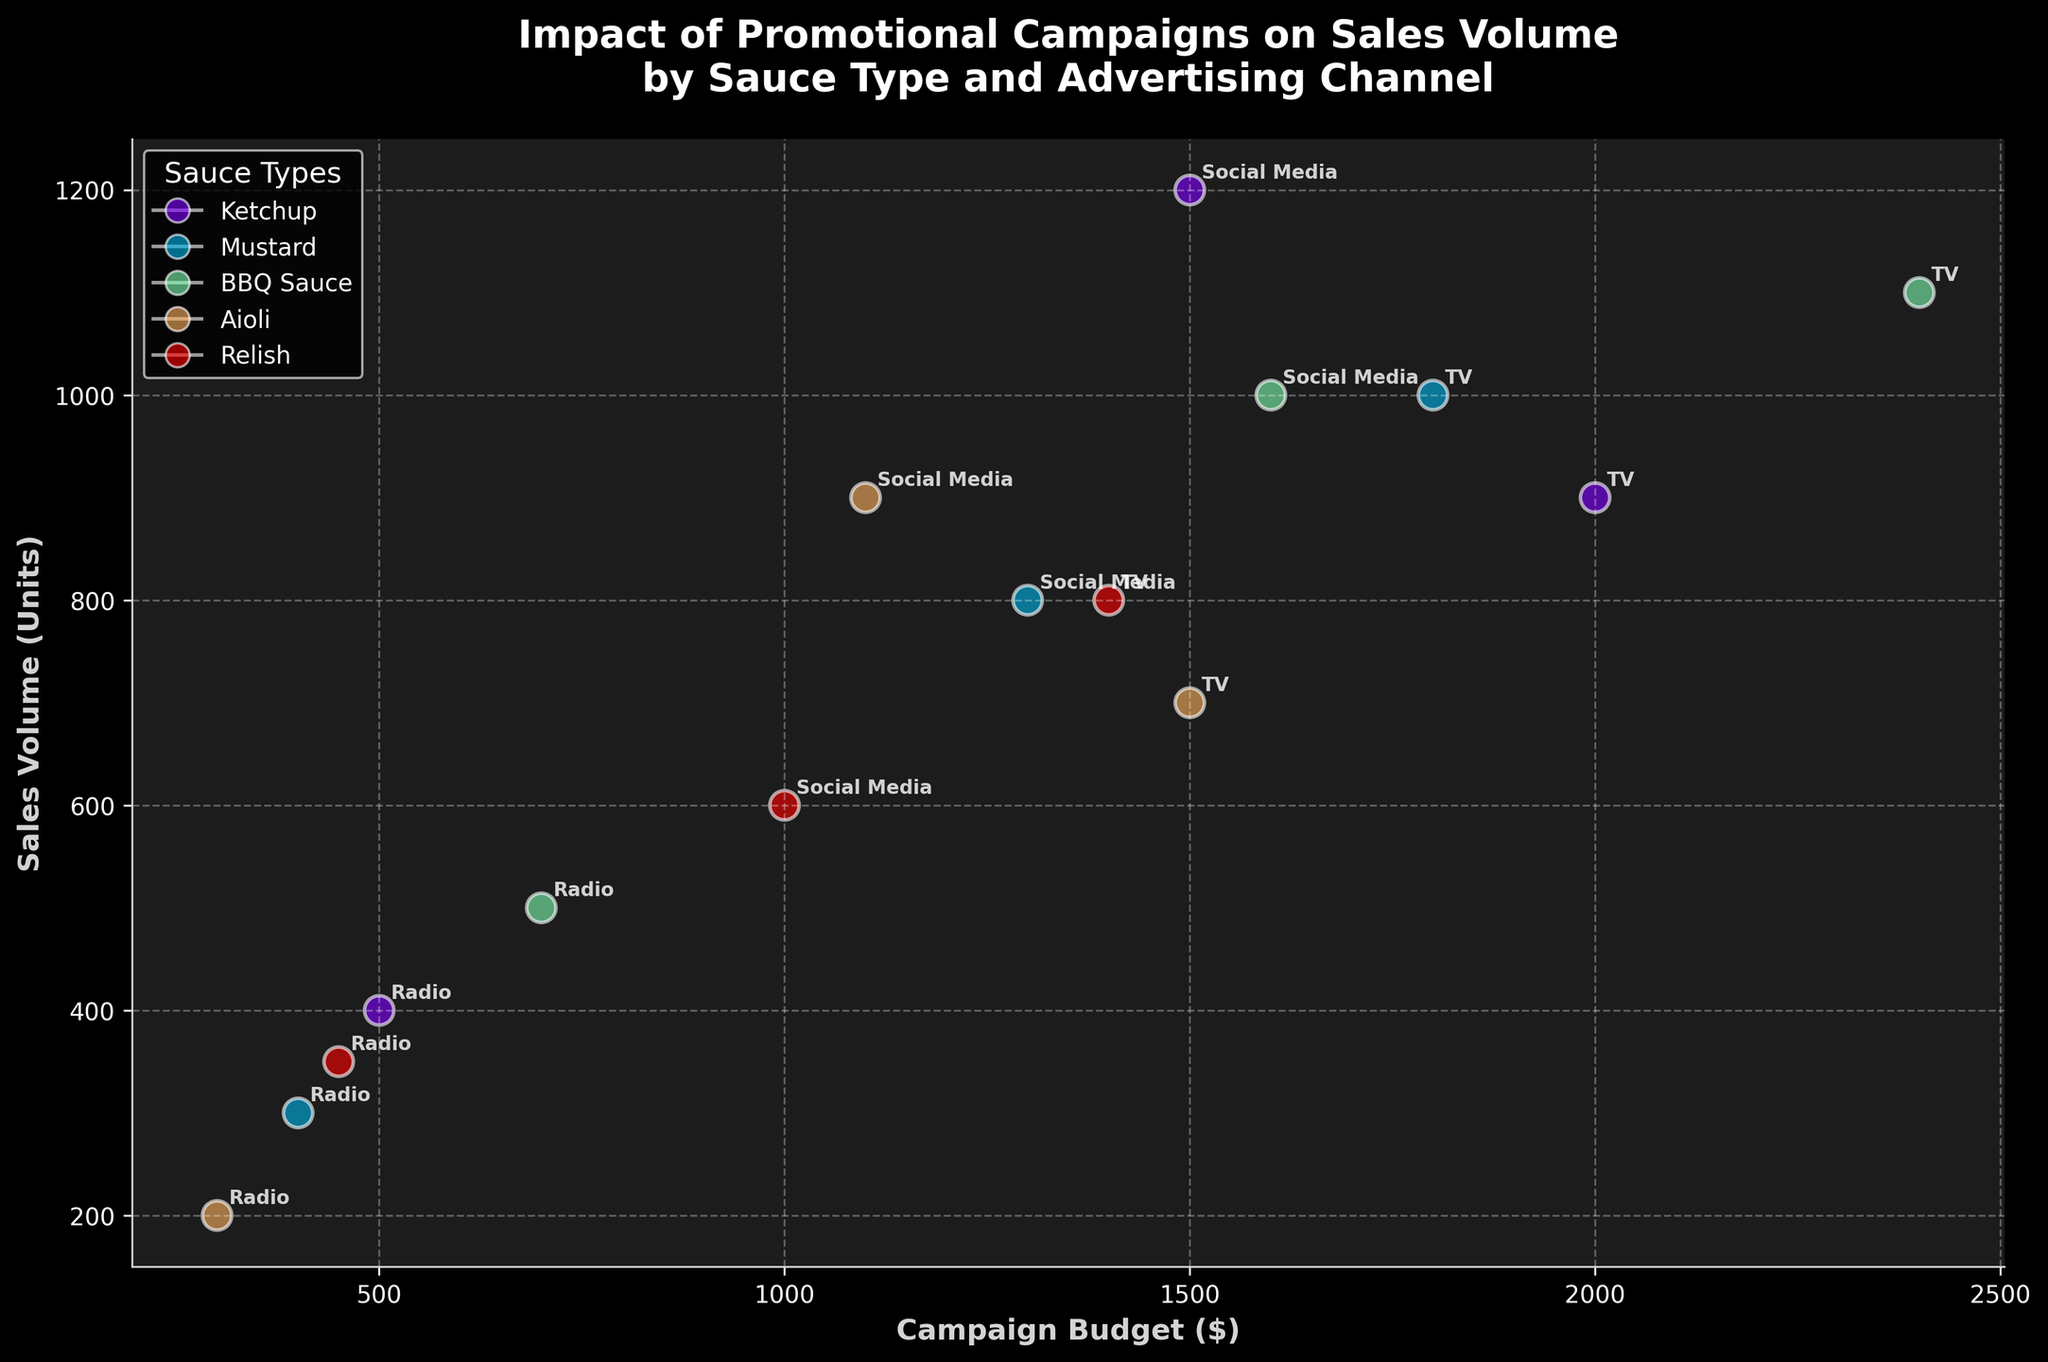What's the title of the figure? The title of the figure can be read at the top of the chart, and it states: "Impact of Promotional Campaigns on Sales Volume by Sauce Type and Advertising Channel".
Answer: "Impact of Promotional Campaigns on Sales Volume by Sauce Type and Advertising Channel" Which sauce type had the highest sales volume on Social Media? Referring to the Social Media data points, the highest y-value among all sauce types is identified as Ketchup with a sales volume of 1200 units.
Answer: Ketchup What are the two axes of the figure? The x-axis and y-axis labels can be read directly from the chart. The x-axis is labeled "Campaign Budget ($)", and the y-axis is labeled "Sales Volume (Units)".
Answer: Campaign Budget ($) and Sales Volume (Units) Which advertising channel had the lowest sales volume for Aioli sauce? By looking at the Aioli sauce data points and comparing the y-values for "Social Media", "TV", and "Radio", the "Radio" channel shows the lowest sales volume with 200 units.
Answer: Radio Compare the sales volume of BBQ Sauce between TV and Radio channels. Which one is higher? By comparing the y-values for TV and Radio advertising channels for BBQ Sauce, the TV channel has a higher sales volume with 1100 units compared to Radio's 500 units.
Answer: TV What is the budget range for the promotional campaigns? The x-axis shows the Campaign Budget range. The lowest value is 300 dollars, and the highest value is 2400 dollars.
Answer: 300 to 2400 dollars Which advertising channel has the smallest size bubbles? The size of the bubbles corresponds to the Campaign Duration. All campaigns are 30 days long, so the bubble sizes are consistently the same.
Answer: All are the same size Considering all sauce types, which advertising channel appears the most frequently? By counting the occurrences of "Social Media", "TV", and "Radio" across all data points, they each appear five times. Hence, frequency is the same across all channels.
Answer: All are equally frequent Calculate the average sales volume for each channel across all sauce types. Summing and averaging the sales volumes for each channel:
- Social Media: (1200 + 800 + 1000 + 900 + 600)/5 = 900
- TV: (900 + 1000 + 1100 + 700 + 800)/5 = 900
- Radio: (400 + 300 + 500 + 200 + 350)/5 = 350
Answer: Social Media: 900, TV: 900, Radio: 350 